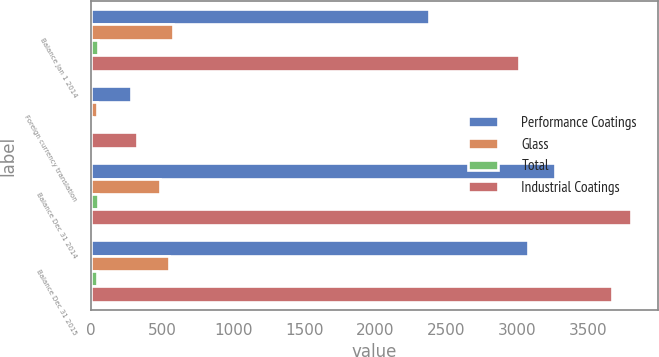<chart> <loc_0><loc_0><loc_500><loc_500><stacked_bar_chart><ecel><fcel>Balance Jan 1 2014<fcel>Foreign currency translation<fcel>Balance Dec 31 2014<fcel>Balance Dec 31 2015<nl><fcel>Performance Coatings<fcel>2381<fcel>279<fcel>3267<fcel>3073<nl><fcel>Glass<fcel>575<fcel>42<fcel>486<fcel>552<nl><fcel>Total<fcel>52<fcel>4<fcel>48<fcel>44<nl><fcel>Industrial Coatings<fcel>3008<fcel>325<fcel>3801<fcel>3669<nl></chart> 